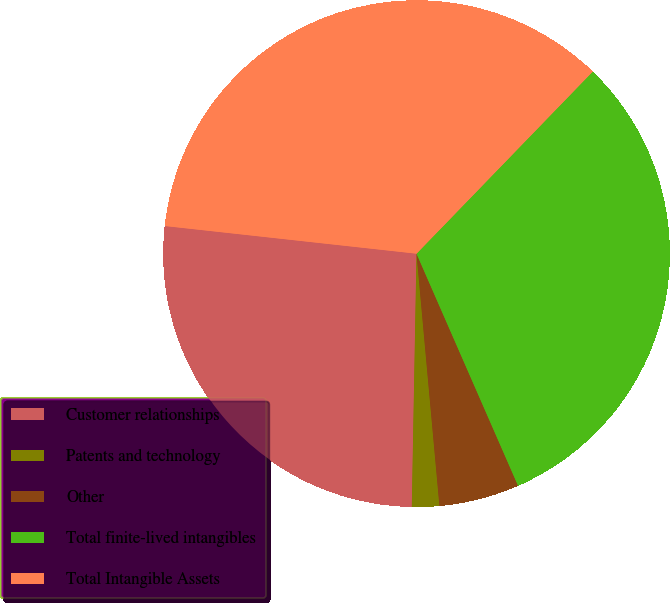Convert chart to OTSL. <chart><loc_0><loc_0><loc_500><loc_500><pie_chart><fcel>Customer relationships<fcel>Patents and technology<fcel>Other<fcel>Total finite-lived intangibles<fcel>Total Intangible Assets<nl><fcel>26.45%<fcel>1.74%<fcel>5.12%<fcel>31.2%<fcel>35.5%<nl></chart> 